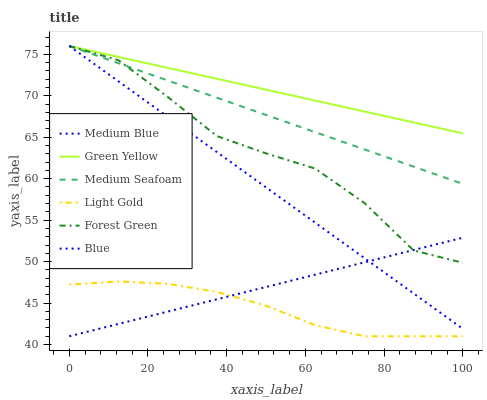Does Light Gold have the minimum area under the curve?
Answer yes or no. Yes. Does Green Yellow have the maximum area under the curve?
Answer yes or no. Yes. Does Medium Blue have the minimum area under the curve?
Answer yes or no. No. Does Medium Blue have the maximum area under the curve?
Answer yes or no. No. Is Medium Blue the smoothest?
Answer yes or no. Yes. Is Forest Green the roughest?
Answer yes or no. Yes. Is Forest Green the smoothest?
Answer yes or no. No. Is Medium Blue the roughest?
Answer yes or no. No. Does Medium Blue have the lowest value?
Answer yes or no. Yes. Does Forest Green have the lowest value?
Answer yes or no. No. Does Medium Seafoam have the highest value?
Answer yes or no. Yes. Does Medium Blue have the highest value?
Answer yes or no. No. Is Light Gold less than Green Yellow?
Answer yes or no. Yes. Is Forest Green greater than Light Gold?
Answer yes or no. Yes. Does Medium Seafoam intersect Forest Green?
Answer yes or no. Yes. Is Medium Seafoam less than Forest Green?
Answer yes or no. No. Is Medium Seafoam greater than Forest Green?
Answer yes or no. No. Does Light Gold intersect Green Yellow?
Answer yes or no. No. 